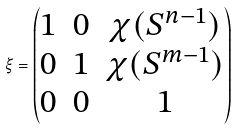Convert formula to latex. <formula><loc_0><loc_0><loc_500><loc_500>\xi = \begin{pmatrix} 1 & 0 & \chi ( S ^ { n - 1 } ) \\ 0 & 1 & \chi ( S ^ { m - 1 } ) \\ 0 & 0 & 1 \end{pmatrix}</formula> 